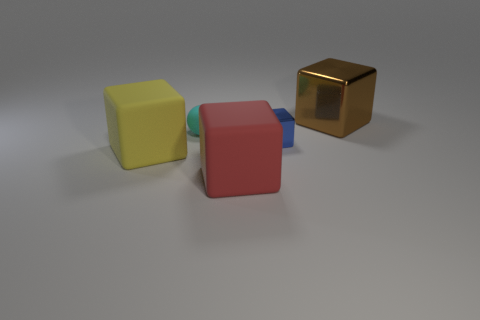What number of other things are the same size as the red block?
Make the answer very short. 2. Does the big object behind the yellow object have the same color as the small ball?
Provide a succinct answer. No. Is the number of blue metal blocks that are in front of the tiny blue shiny thing greater than the number of large blue cylinders?
Keep it short and to the point. No. Is there anything else that is the same color as the small metal thing?
Your response must be concise. No. There is a large thing behind the small block that is on the right side of the big yellow block; what shape is it?
Provide a short and direct response. Cube. Are there more shiny blocks than big brown things?
Your answer should be compact. Yes. How many objects are both behind the yellow thing and on the right side of the ball?
Your answer should be very brief. 2. There is a thing right of the small blue metal block; what number of big brown blocks are left of it?
Provide a short and direct response. 0. What number of objects are large matte objects in front of the big shiny cube or things that are to the left of the brown metal thing?
Your response must be concise. 4. There is a red object that is the same shape as the small blue metal object; what material is it?
Provide a short and direct response. Rubber. 